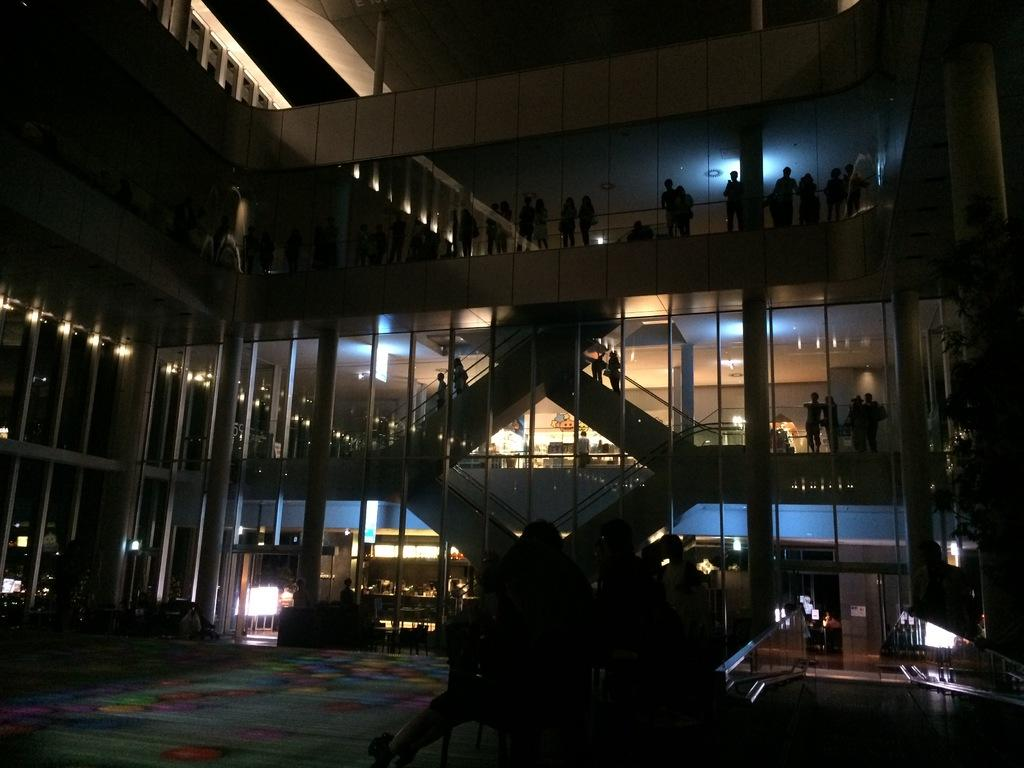What type of structure is depicted in the image? There is a building with pillars in the image. What architectural features can be seen on the building? The building has staircases and lights. Are there any people present in the image? Yes, there are people on the building and in front of the building. What can be seen on the right side of the image? There is a tree on the right side of the image. What type of grain is being harvested by the scarecrow in the image? There is no scarecrow or grain present in the image; it features a building with pillars, lights, and people. What is the interest rate for the loan taken out by the people in the image? There is no information about loans or interest rates in the image; it focuses on a building, people, and a tree. 